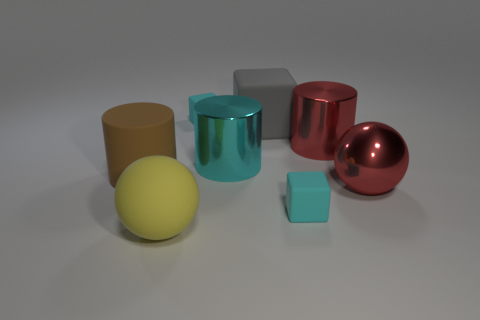How many tiny rubber cubes are behind the block that is in front of the large brown rubber object to the left of the large cyan cylinder?
Your answer should be very brief. 1. What is the color of the small matte thing to the left of the tiny cyan rubber thing in front of the large brown matte cylinder?
Provide a short and direct response. Cyan. Is there a cyan matte cube of the same size as the metal sphere?
Give a very brief answer. No. What material is the big brown thing behind the cyan matte thing in front of the rubber block on the left side of the big cyan metallic object made of?
Offer a very short reply. Rubber. There is a tiny cyan object that is behind the large rubber block; how many tiny matte blocks are in front of it?
Offer a terse response. 1. There is a cyan matte thing behind the cyan metallic cylinder; is its size the same as the big red sphere?
Make the answer very short. No. How many big red metallic objects have the same shape as the big yellow thing?
Ensure brevity in your answer.  1. What shape is the gray matte object?
Your answer should be compact. Cube. Is the number of big red cylinders that are in front of the metallic sphere the same as the number of red cylinders?
Provide a succinct answer. No. Does the tiny block that is to the right of the gray thing have the same material as the brown cylinder?
Provide a short and direct response. Yes. 